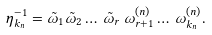Convert formula to latex. <formula><loc_0><loc_0><loc_500><loc_500>\eta _ { k _ { n } } ^ { - 1 } = \tilde { \omega } _ { 1 } \tilde { \omega } _ { 2 } \dots \, \tilde { \omega } _ { r } \, \omega _ { r + 1 } ^ { ( n ) } \dots \, \omega _ { k _ { n } } ^ { ( n ) } .</formula> 